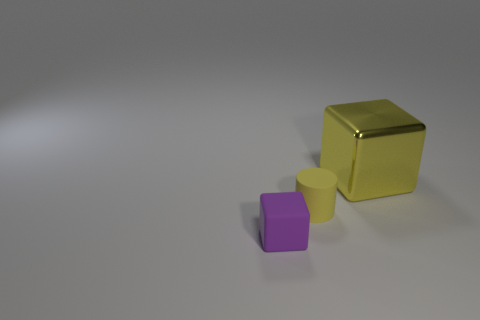Add 3 big red things. How many objects exist? 6 Subtract all purple blocks. How many blocks are left? 1 Subtract all cubes. How many objects are left? 1 Add 2 large metallic cubes. How many large metallic cubes exist? 3 Subtract 0 red cylinders. How many objects are left? 3 Subtract all gray cylinders. Subtract all green cubes. How many cylinders are left? 1 Subtract all brown cylinders. How many purple cubes are left? 1 Subtract all small yellow objects. Subtract all yellow rubber cylinders. How many objects are left? 1 Add 1 metallic things. How many metallic things are left? 2 